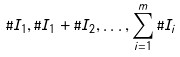Convert formula to latex. <formula><loc_0><loc_0><loc_500><loc_500>\# I _ { 1 } , \# I _ { 1 } + \# I _ { 2 } , \dots , \sum _ { i = 1 } ^ { m } \# I _ { i }</formula> 